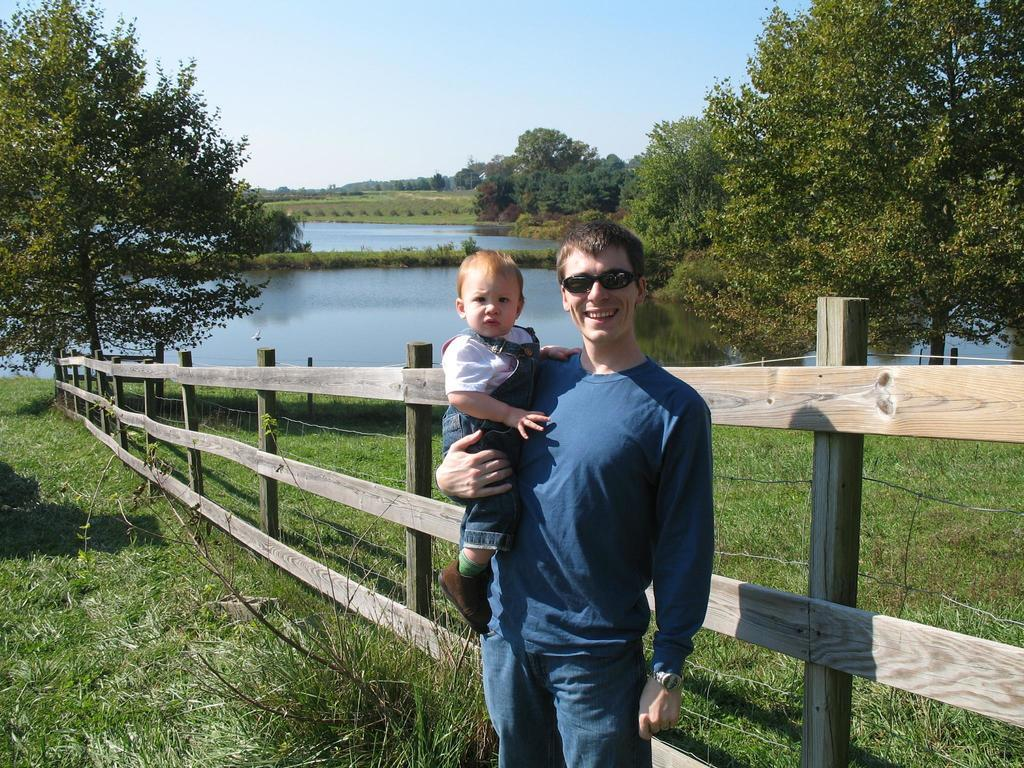What is the man in the image doing? The man is holding a baby in the image. Can you describe the man's appearance? The man is wearing spectacles and is smiling. What can be seen in the background of the image? There is a fence, grass, trees, and water visible in the image. What type of pets can be seen playing with the gold in the image? There are no pets or gold present in the image. Can you describe the toad's habitat in the image? There is no toad present in the image. 